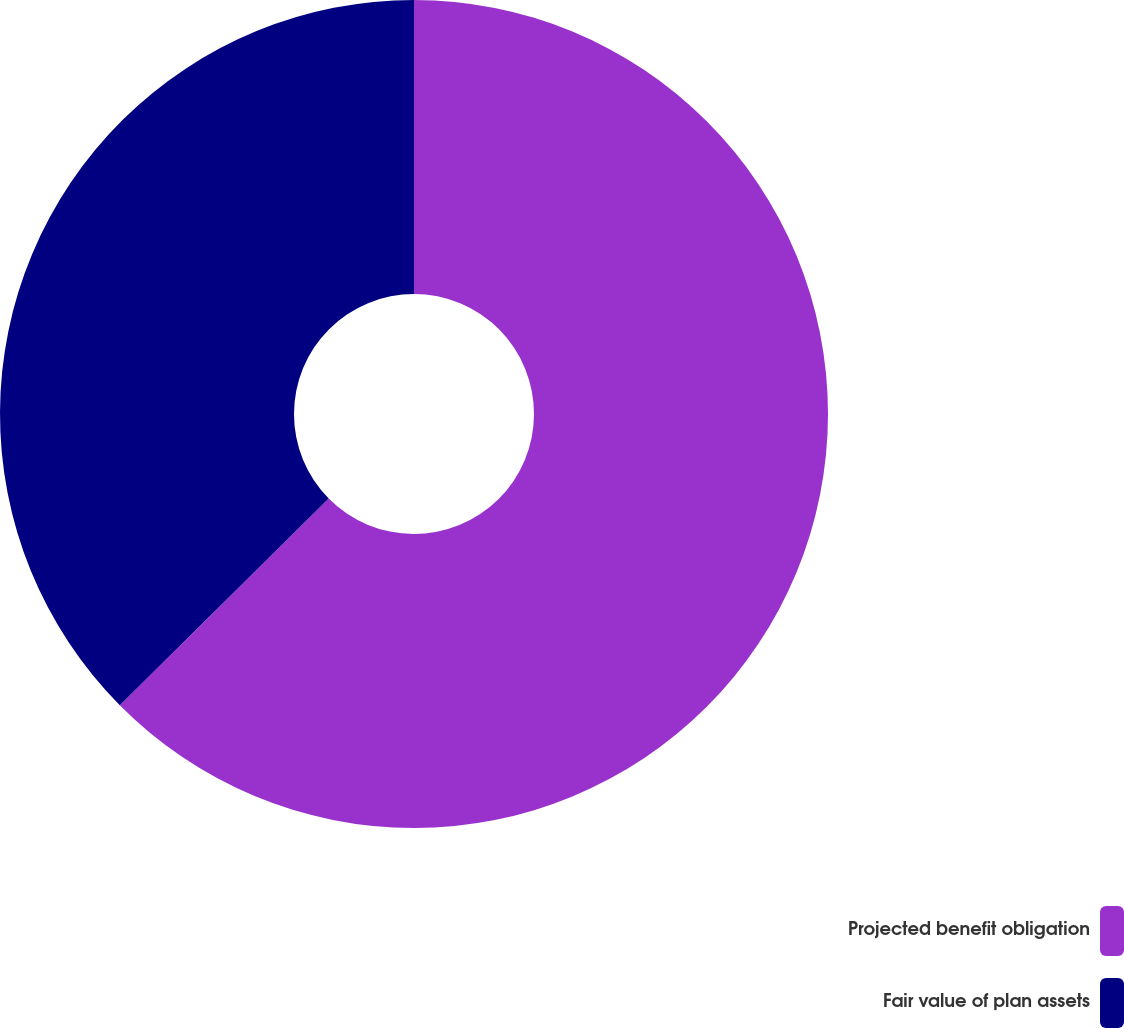Convert chart. <chart><loc_0><loc_0><loc_500><loc_500><pie_chart><fcel>Projected benefit obligation<fcel>Fair value of plan assets<nl><fcel>62.58%<fcel>37.42%<nl></chart> 